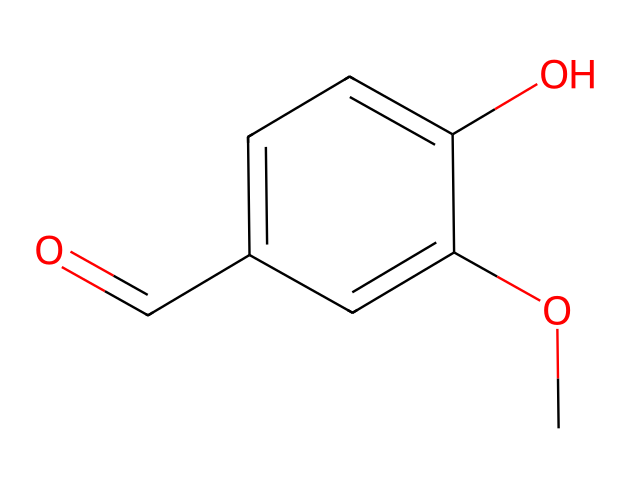What is the molecular formula of vanillin? To determine the molecular formula, count the number of each type of atom present in the SMILES representation. The structure has 8 carbon atoms, 8 hydrogen atoms, and 3 oxygen atoms, leading to the formula C8H8O3.
Answer: C8H8O3 How many hydroxyl groups are present in vanillin? In the structure, a hydroxyl group (-OH) can be identified by looking for -O connected to a carbon atom. There is one hydroxyl group present in vanillin due to one -OH connected to the aromatic ring.
Answer: one What type of functional group is present in vanillin besides the hydroxyl group? The presence of a carbonyl group (C=O) is indicated by the -O=C portion of the SMILES representation. This functional group is characteristic of aldehydes in this structure.
Answer: aldehyde How many rings are present in the structure of vanillin? The provided SMILES denotes a single aromatic ring, which consists of six carbon atoms interconnected in a cyclic manner; hence, there is one ring in the compound.
Answer: one What is the significance of the methoxy group in vanillin? The methoxy group (-OCH3) is indicated in the structure and contributes to the flavor profile and odor properties of vanillin. It enhances the sweet and creamy aspects of the vanilla flavor.
Answer: sweet What type of compound is vanillin classified as? Vanillin, based on its structural features (an aromatic compound with aldehyde and hydroxyl groups), is classified as a phenolic compound, commonly used as a flavoring agent.
Answer: phenolic compound 